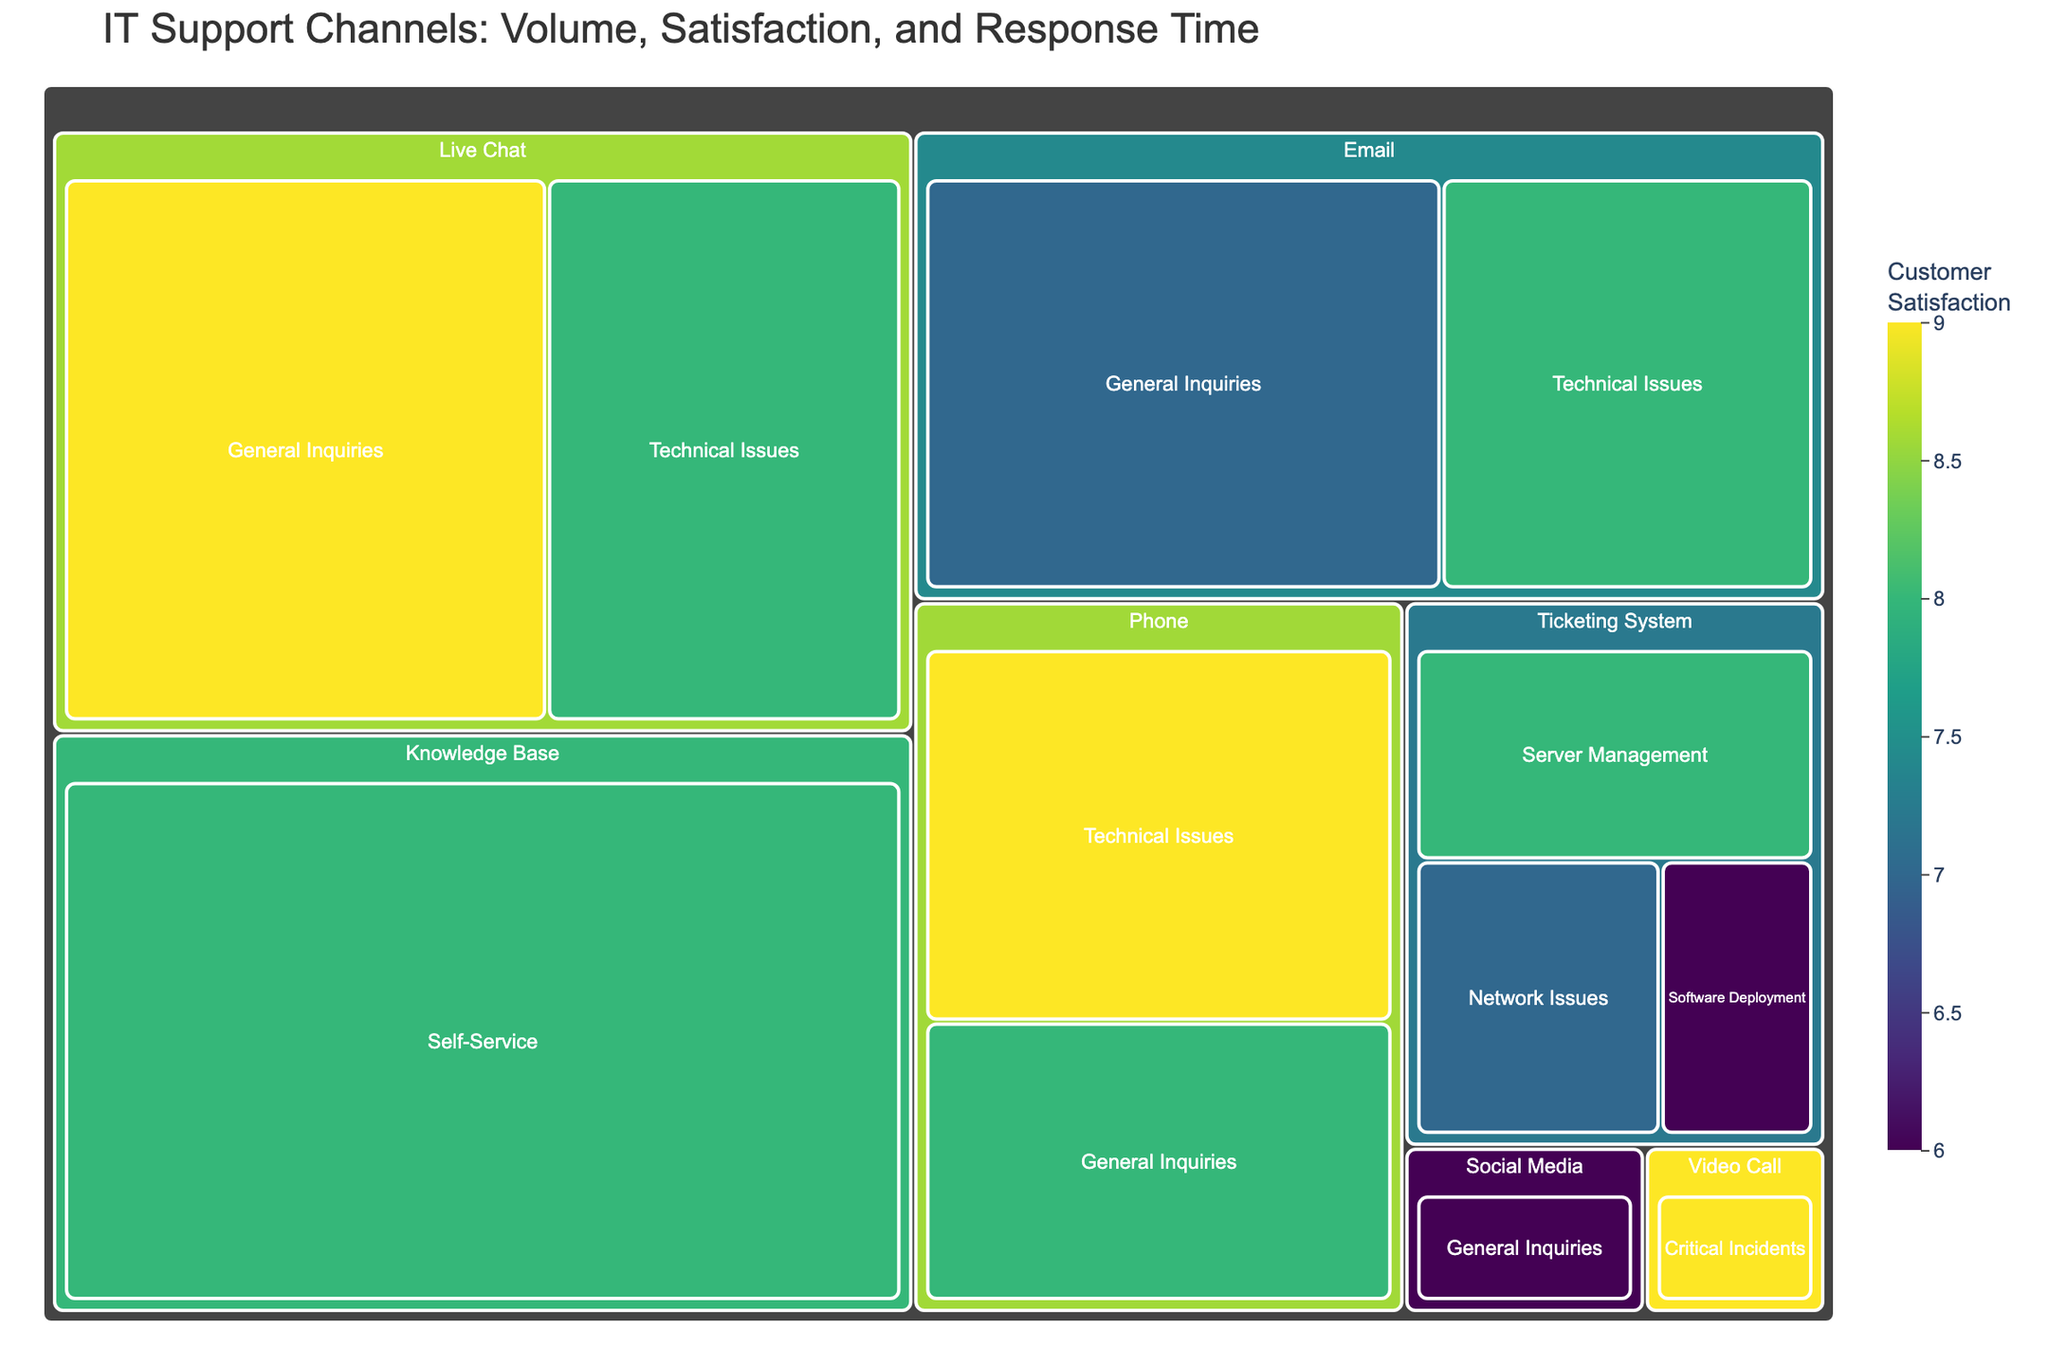What's the title of the treemap figure? The title is located at the top of the treemap and provides a summary of what is being depicted. It reads, "IT Support Channels: Volume, Satisfaction, and Response Time".
Answer: IT Support Channels: Volume, Satisfaction, and Response Time Which communication channel has the highest volume for General Inquiries? By examining the size of the blocks in the "General Inquiries" category, the largest block corresponds to Live Chat with a volume of 300.
Answer: Live Chat What is the overall customer satisfaction for Technical Issues via Phone? Locate the segment labeled "Technical Issues" under the "Phone" category. The color and hover data indicate that the customer satisfaction score is 9.
Answer: 9 Compare the response times for Technical Issues between Live Chat and Phone. Which one is faster? By observing the "Technical Issues" segments under "Live Chat" and "Phone", the response time for Live Chat is 10 minutes and for Phone, it is 20 minutes. Live Chat is faster.
Answer: Live Chat What is the average response time for Email communication channels? There are two Email communication channels: General Inquiries (120 minutes) and Technical Issues (90 minutes). The average response time is calculated as (120 + 90) / 2 = 105 minutes.
Answer: 105 minutes What category has the highest customer satisfaction, and which communication channel achieves this within that category? By evaluating customer satisfaction scores across categories and channels, "Video Call" in the "Critical Incidents" category has the highest score of 9.
Answer: Critical Incidents, Video Call Which communication channel has the shortest response time and what is its category? The shortest response time is 1 minute, found under the "Knowledge Base" channel in the "Self-Service" category.
Answer: Knowledge Base, Self-Service What is the difference in customer satisfaction between Social Media and Knowledge Base for their respective categories? Customer satisfaction for Social Media in General Inquiries is 6, and for Knowledge Base in Self-Service, it is 8. The difference is 8 - 6 = 2.
Answer: 2 Among all the categories, which one has the highest diversity in customer satisfaction scores? By comparing the range of customer satisfaction scores across all categories, "Ticketing System" shows a diversity of scores ranging from 6 to 8, indicating it has the highest diversity in this context.
Answer: Ticketing System Which category and channel combination has the smallest volume, and what is the response time and satisfaction for this combination? The smallest volume block is identified under "Video Call" in the "Critical Incidents" category with a volume of 30. The response time is 30 minutes and customer satisfaction is 9.
Answer: Video Call, Critical Incidents, 30 minutes, 9 